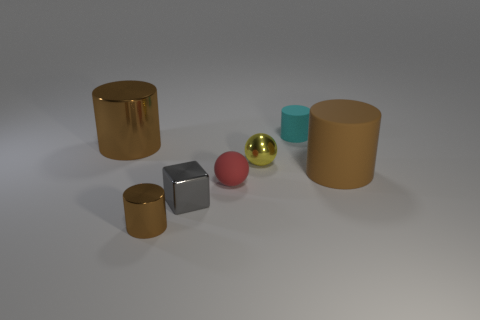What size is the other shiny object that is the same color as the big metallic thing?
Provide a short and direct response. Small. There is a rubber thing that is in front of the big brown shiny cylinder and right of the red matte ball; what shape is it?
Ensure brevity in your answer.  Cylinder. There is a thing that is both behind the small yellow shiny object and on the left side of the small gray metallic cube; what is its size?
Keep it short and to the point. Large. Does the large rubber thing have the same shape as the tiny yellow metallic object?
Your answer should be compact. No. Are there any tiny cyan things made of the same material as the red ball?
Offer a terse response. Yes. There is a small object that is both behind the small brown shiny thing and in front of the small red thing; what color is it?
Offer a terse response. Gray. What is the small thing in front of the tiny gray thing made of?
Offer a terse response. Metal. Are there any big brown rubber objects of the same shape as the cyan rubber thing?
Ensure brevity in your answer.  Yes. What number of other things are there of the same shape as the brown matte object?
Make the answer very short. 3. Do the small red rubber object and the large brown thing that is on the right side of the tiny cyan cylinder have the same shape?
Ensure brevity in your answer.  No. 